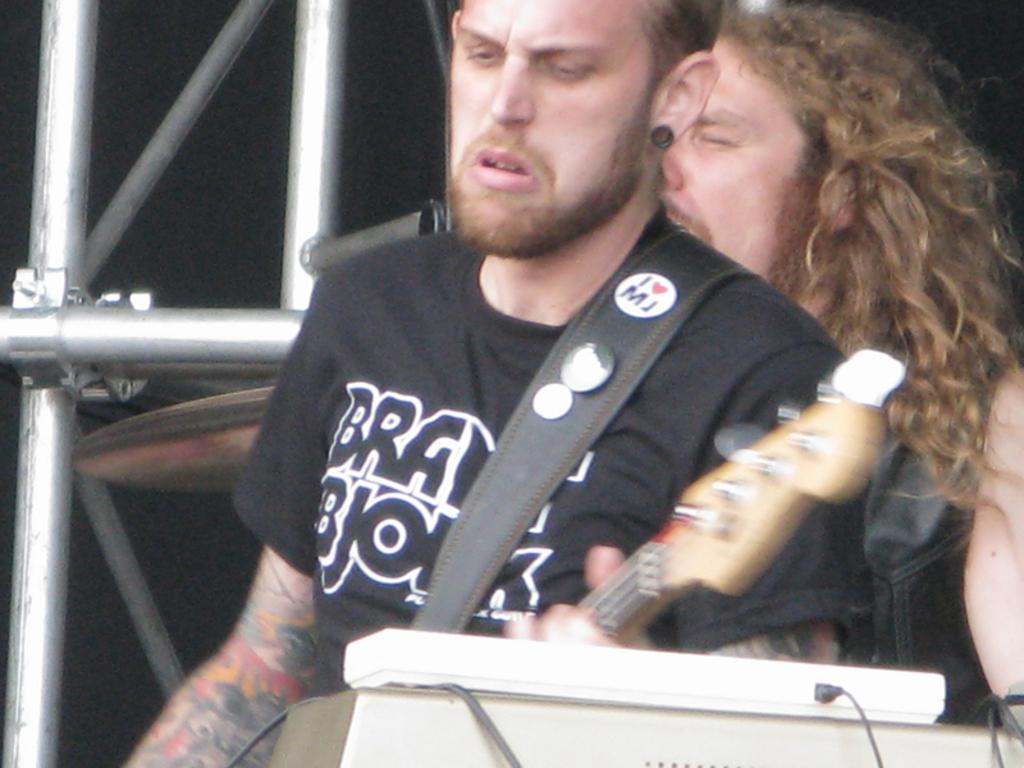How would you summarize this image in a sentence or two? In the picture there are two person standing in front of a microphone and playing guitar there are some poles near to them. 